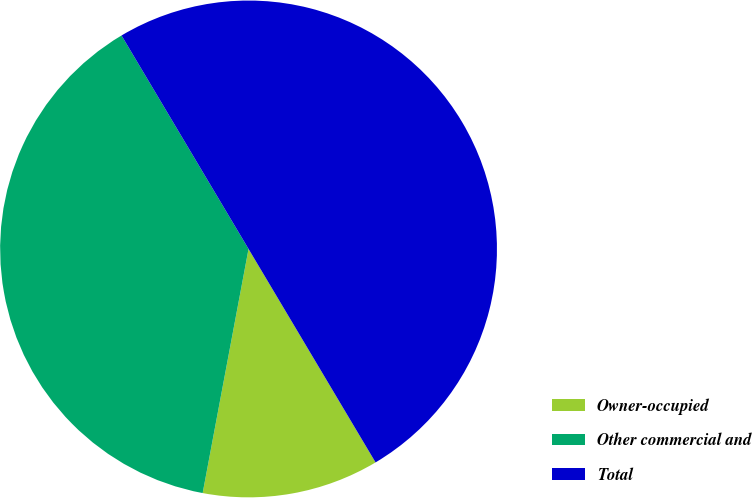Convert chart. <chart><loc_0><loc_0><loc_500><loc_500><pie_chart><fcel>Owner-occupied<fcel>Other commercial and<fcel>Total<nl><fcel>11.5%<fcel>38.5%<fcel>50.0%<nl></chart> 